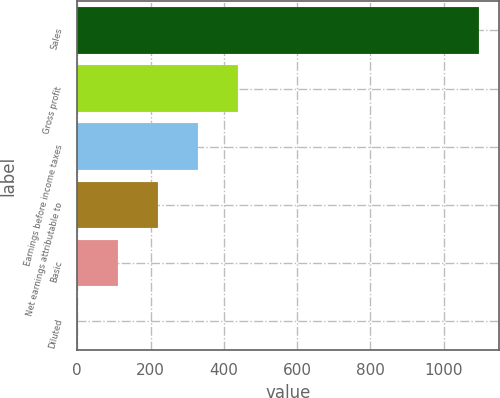Convert chart. <chart><loc_0><loc_0><loc_500><loc_500><bar_chart><fcel>Sales<fcel>Gross profit<fcel>Earnings before income taxes<fcel>Net earnings attributable to<fcel>Basic<fcel>Diluted<nl><fcel>1096.6<fcel>439.03<fcel>329.44<fcel>219.85<fcel>110.26<fcel>0.67<nl></chart> 